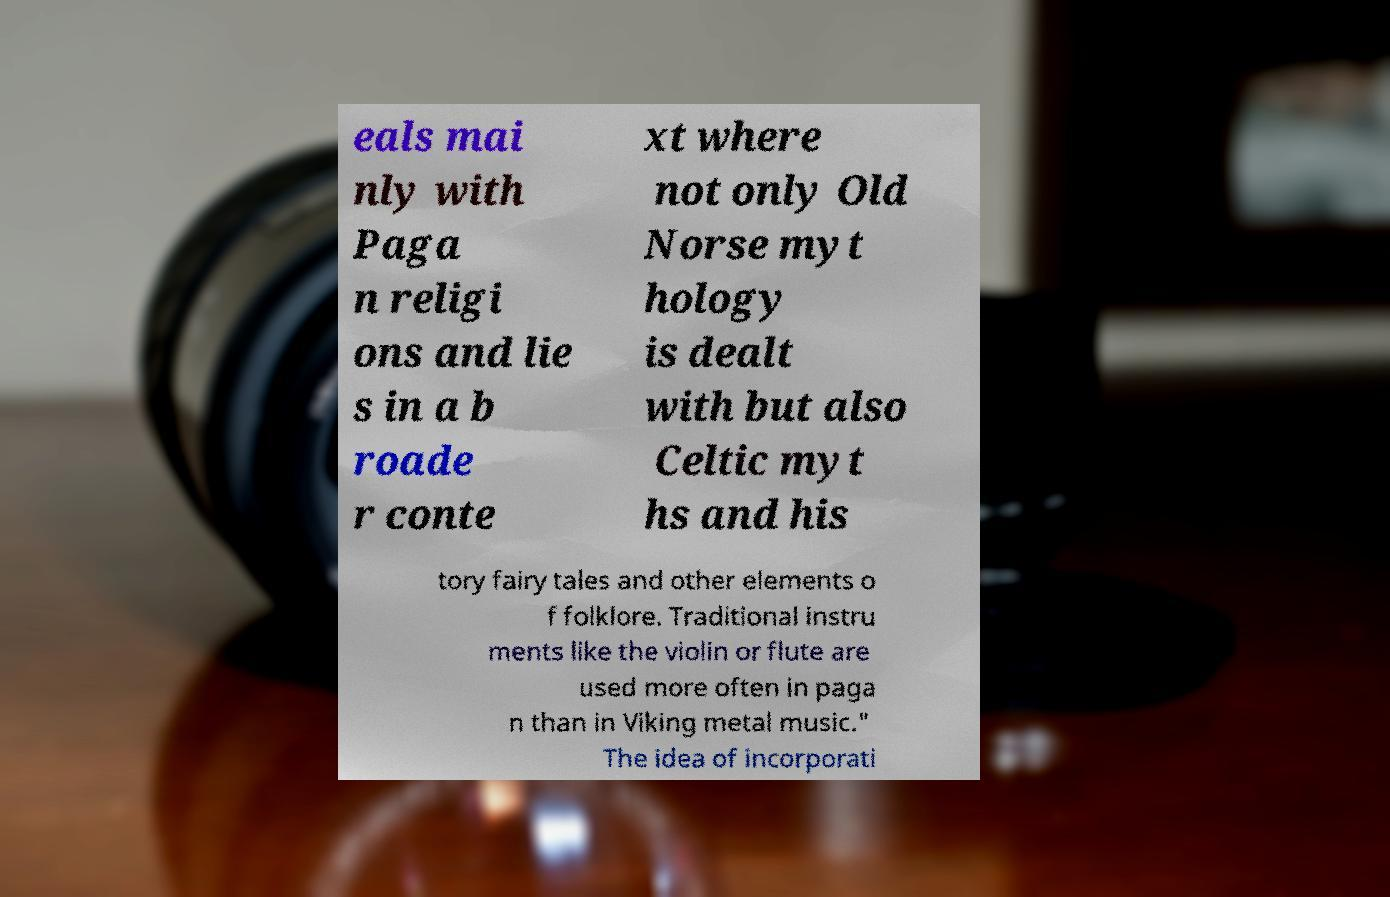I need the written content from this picture converted into text. Can you do that? eals mai nly with Paga n religi ons and lie s in a b roade r conte xt where not only Old Norse myt hology is dealt with but also Celtic myt hs and his tory fairy tales and other elements o f folklore. Traditional instru ments like the violin or flute are used more often in paga n than in Viking metal music." The idea of incorporati 